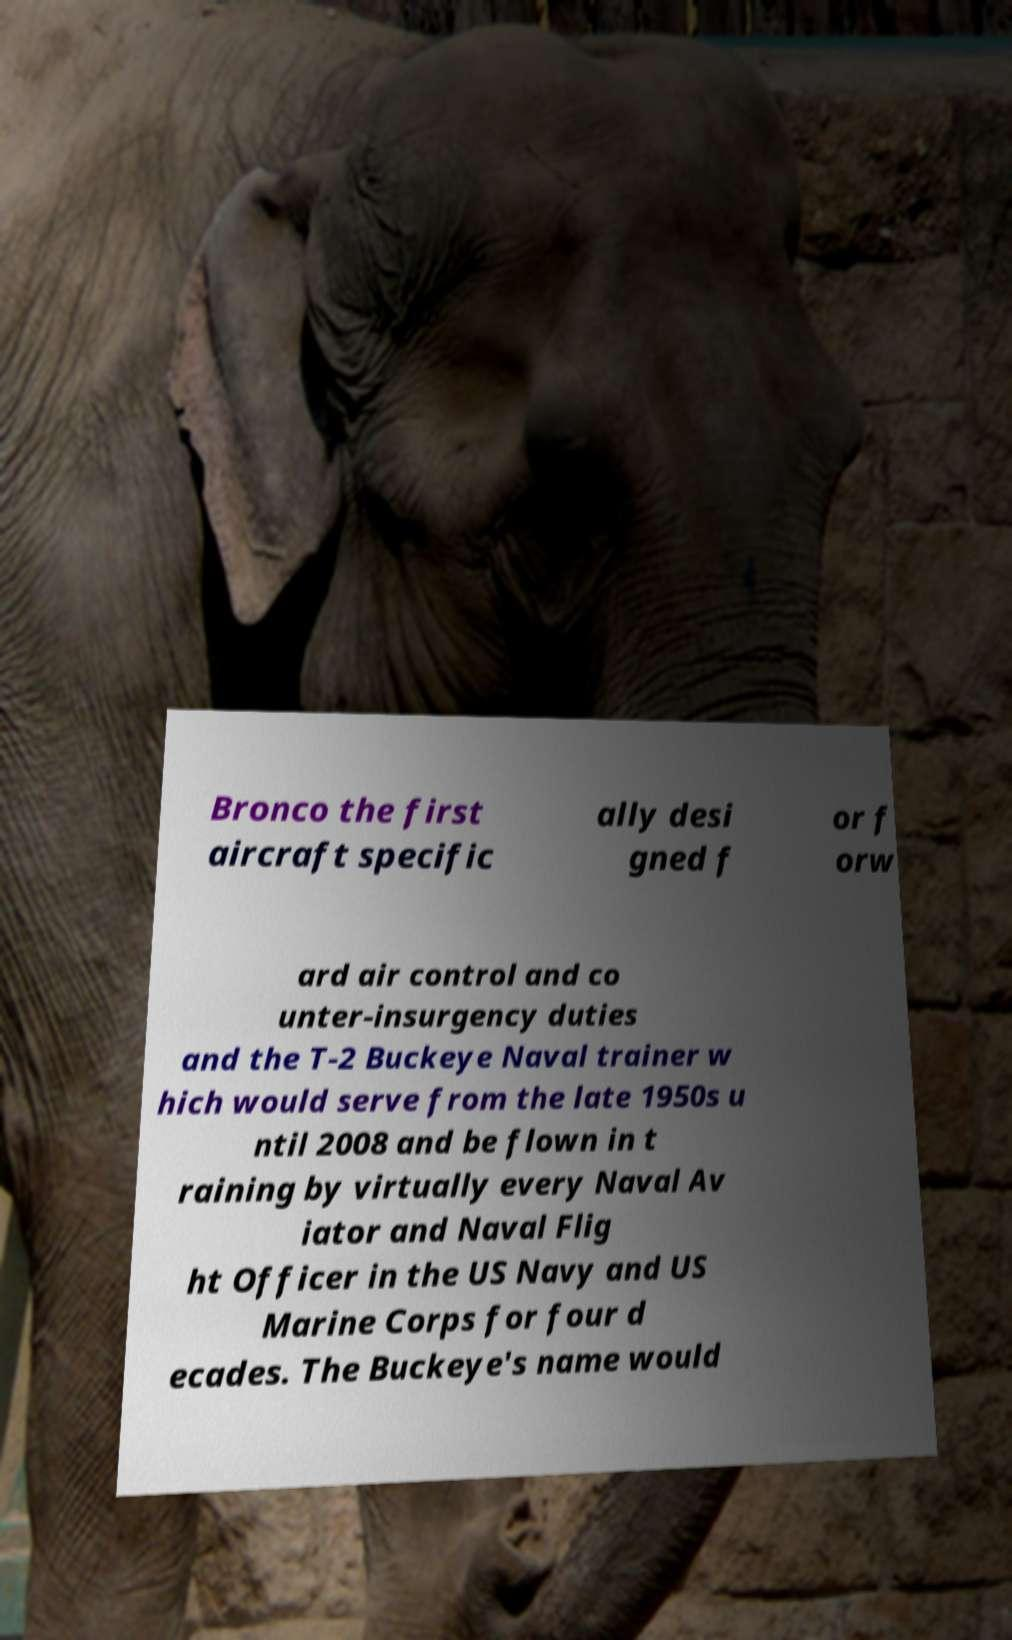Can you accurately transcribe the text from the provided image for me? Bronco the first aircraft specific ally desi gned f or f orw ard air control and co unter-insurgency duties and the T-2 Buckeye Naval trainer w hich would serve from the late 1950s u ntil 2008 and be flown in t raining by virtually every Naval Av iator and Naval Flig ht Officer in the US Navy and US Marine Corps for four d ecades. The Buckeye's name would 